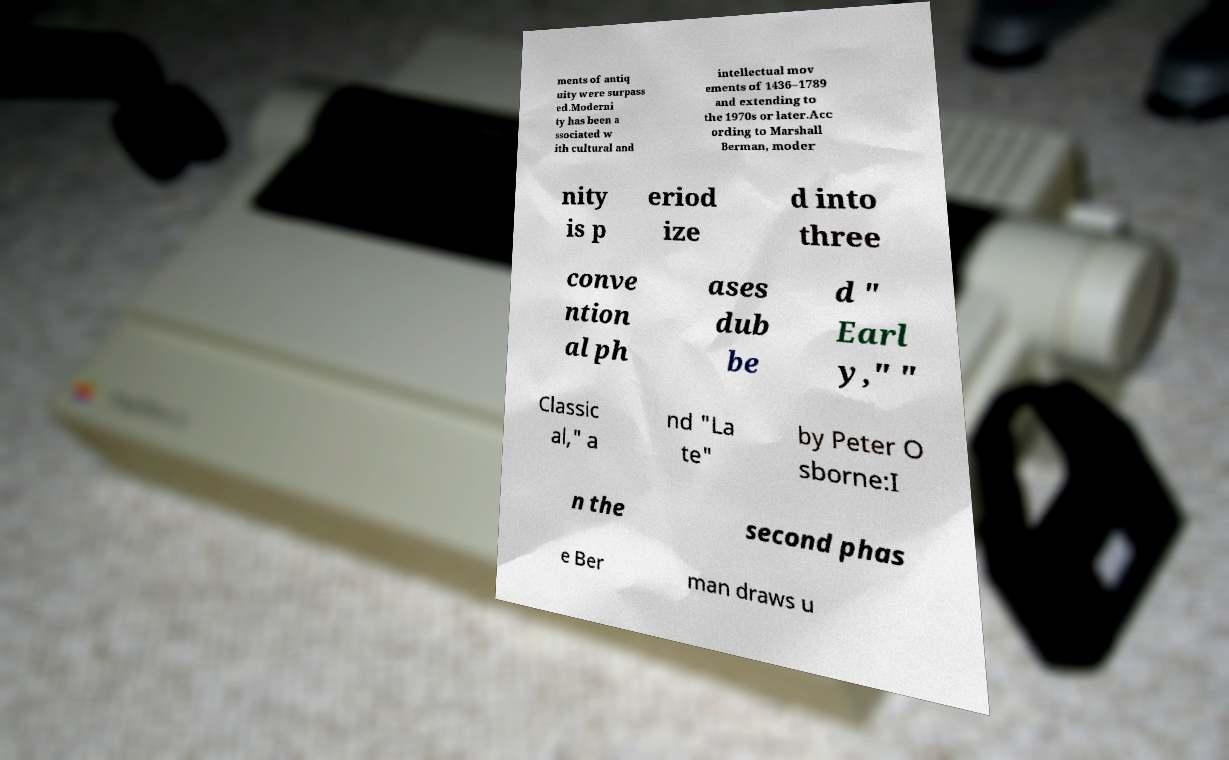I need the written content from this picture converted into text. Can you do that? ments of antiq uity were surpass ed.Moderni ty has been a ssociated w ith cultural and intellectual mov ements of 1436–1789 and extending to the 1970s or later.Acc ording to Marshall Berman, moder nity is p eriod ize d into three conve ntion al ph ases dub be d " Earl y," " Classic al," a nd "La te" by Peter O sborne:I n the second phas e Ber man draws u 